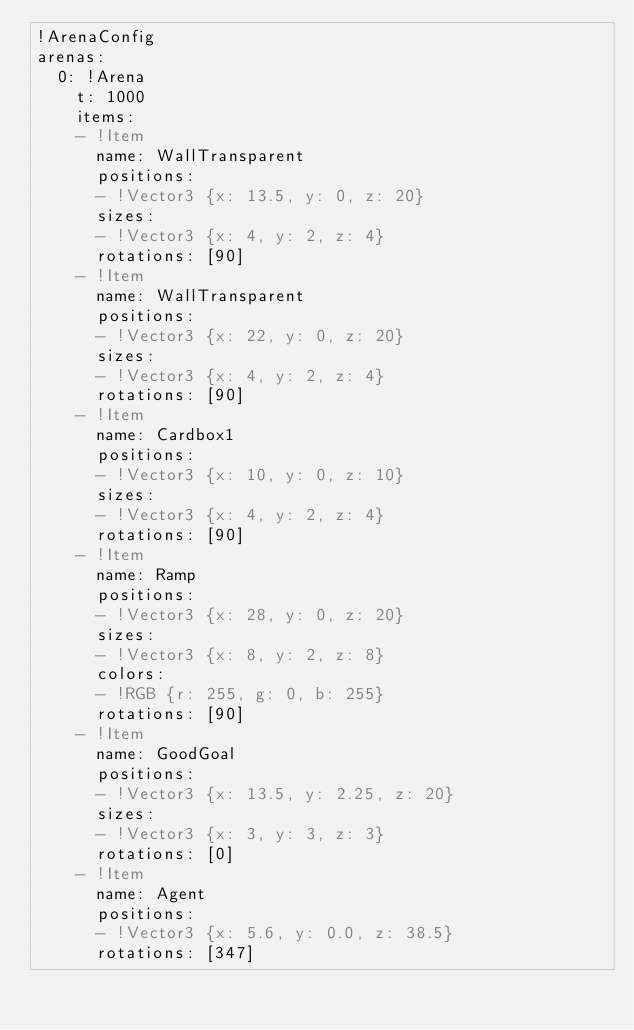Convert code to text. <code><loc_0><loc_0><loc_500><loc_500><_YAML_>!ArenaConfig 
arenas: 
  0: !Arena 
    t: 1000 
    items:
    - !Item 
      name: WallTransparent 
      positions: 
      - !Vector3 {x: 13.5, y: 0, z: 20}
      sizes: 
      - !Vector3 {x: 4, y: 2, z: 4}
      rotations: [90]
    - !Item 
      name: WallTransparent 
      positions: 
      - !Vector3 {x: 22, y: 0, z: 20}
      sizes: 
      - !Vector3 {x: 4, y: 2, z: 4}
      rotations: [90]
    - !Item 
      name: Cardbox1 
      positions: 
      - !Vector3 {x: 10, y: 0, z: 10}
      sizes: 
      - !Vector3 {x: 4, y: 2, z: 4}
      rotations: [90]
    - !Item 
      name: Ramp 
      positions: 
      - !Vector3 {x: 28, y: 0, z: 20}
      sizes: 
      - !Vector3 {x: 8, y: 2, z: 8}
      colors: 
      - !RGB {r: 255, g: 0, b: 255}
      rotations: [90]
    - !Item 
      name: GoodGoal 
      positions: 
      - !Vector3 {x: 13.5, y: 2.25, z: 20}
      sizes: 
      - !Vector3 {x: 3, y: 3, z: 3}
      rotations: [0]
    - !Item 
      name: Agent 
      positions: 
      - !Vector3 {x: 5.6, y: 0.0, z: 38.5}
      rotations: [347]
</code> 